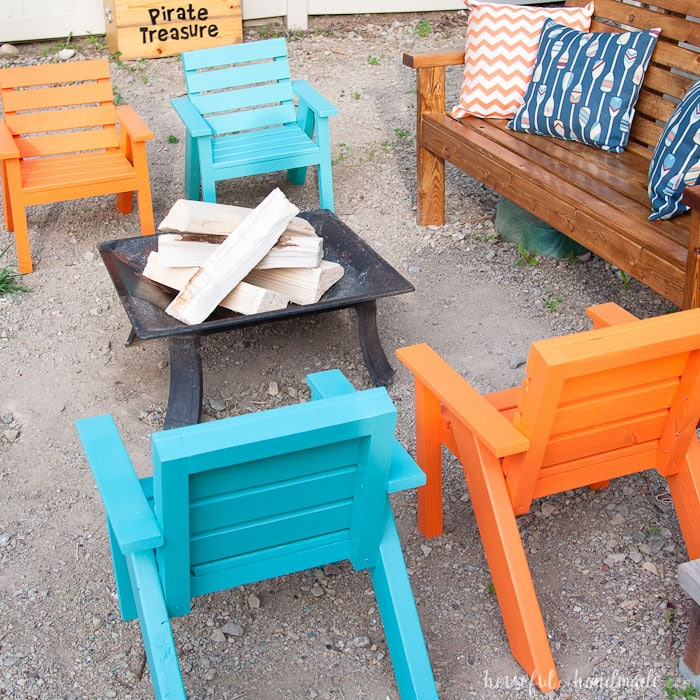Based on the arrangement and the items present in the image, what kind of social event or activity does this setting appear to be prepared for, and what elements support that conclusion? The setting appears to be designed for a casual and cozy outdoor social gathering, such as a small party, a get-together, or an evening around a fire pit. Several elements support this conclusion. First, the arrangement of brightly colored Adirondack chairs and a wooden bench with decorative pillows surrounding a fire pit facilitates conversation and adds comfort, inviting guests to sit and relax. The firewood placed in the pit suggests the potential for a fire to provide warmth and enhance ambiance. The whimsical 'Pirate Treasure' sign hints at a playful theme, perhaps suggesting games, a treasure hunt, or activities that incorporate imaginative or themed entertainment into the event. 